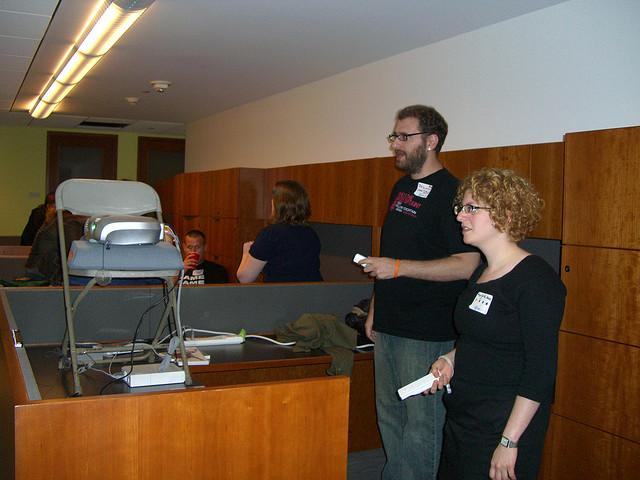What kind of label is on their shirts?

Choices:
A) warning
B) instructional
C) brand
D) name tag name tag 